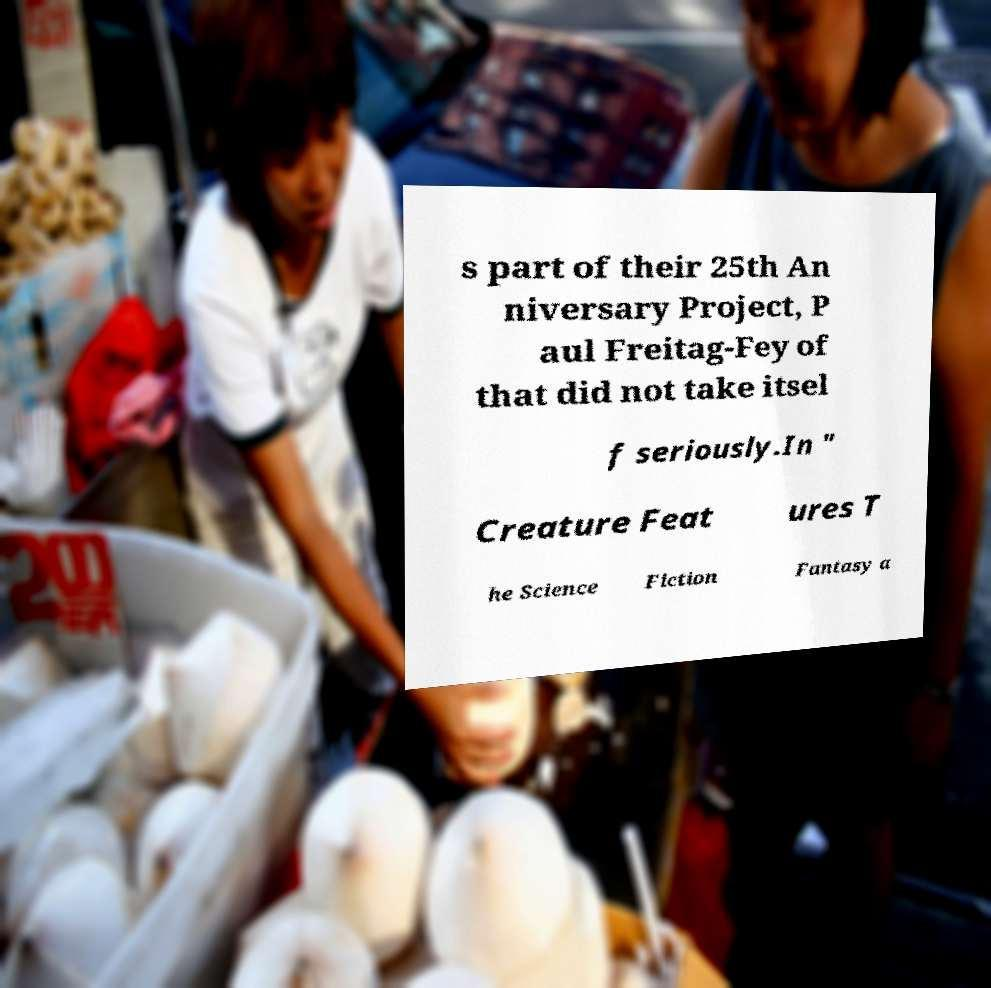Can you accurately transcribe the text from the provided image for me? s part of their 25th An niversary Project, P aul Freitag-Fey of that did not take itsel f seriously.In " Creature Feat ures T he Science Fiction Fantasy a 